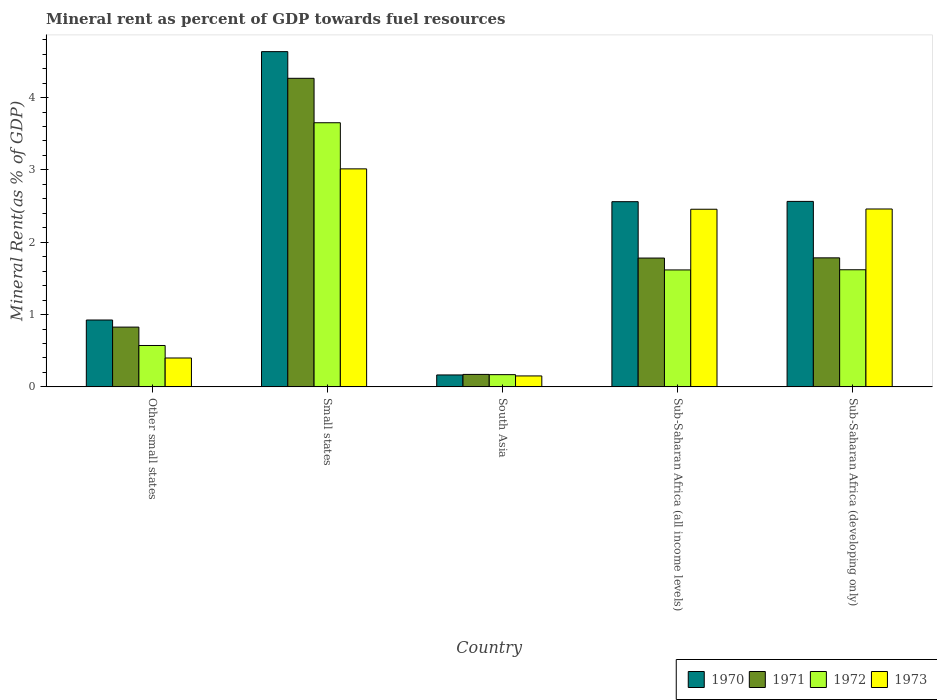Are the number of bars on each tick of the X-axis equal?
Offer a terse response. Yes. How many bars are there on the 1st tick from the left?
Ensure brevity in your answer.  4. How many bars are there on the 4th tick from the right?
Offer a very short reply. 4. What is the label of the 5th group of bars from the left?
Make the answer very short. Sub-Saharan Africa (developing only). What is the mineral rent in 1972 in Sub-Saharan Africa (developing only)?
Your answer should be compact. 1.62. Across all countries, what is the maximum mineral rent in 1973?
Give a very brief answer. 3.01. Across all countries, what is the minimum mineral rent in 1973?
Ensure brevity in your answer.  0.15. In which country was the mineral rent in 1970 maximum?
Make the answer very short. Small states. What is the total mineral rent in 1972 in the graph?
Ensure brevity in your answer.  7.63. What is the difference between the mineral rent in 1973 in Sub-Saharan Africa (all income levels) and that in Sub-Saharan Africa (developing only)?
Keep it short and to the point. -0. What is the difference between the mineral rent in 1971 in Sub-Saharan Africa (all income levels) and the mineral rent in 1972 in South Asia?
Give a very brief answer. 1.61. What is the average mineral rent in 1971 per country?
Keep it short and to the point. 1.77. What is the difference between the mineral rent of/in 1970 and mineral rent of/in 1971 in Sub-Saharan Africa (all income levels)?
Provide a short and direct response. 0.78. What is the ratio of the mineral rent in 1973 in Small states to that in South Asia?
Your answer should be compact. 19.93. Is the mineral rent in 1972 in Other small states less than that in Sub-Saharan Africa (developing only)?
Provide a short and direct response. Yes. What is the difference between the highest and the second highest mineral rent in 1973?
Make the answer very short. -0.55. What is the difference between the highest and the lowest mineral rent in 1972?
Give a very brief answer. 3.48. In how many countries, is the mineral rent in 1973 greater than the average mineral rent in 1973 taken over all countries?
Your response must be concise. 3. Is the sum of the mineral rent in 1972 in Small states and Sub-Saharan Africa (all income levels) greater than the maximum mineral rent in 1970 across all countries?
Make the answer very short. Yes. What does the 3rd bar from the right in Sub-Saharan Africa (all income levels) represents?
Offer a very short reply. 1971. How many bars are there?
Your response must be concise. 20. What is the difference between two consecutive major ticks on the Y-axis?
Keep it short and to the point. 1. Are the values on the major ticks of Y-axis written in scientific E-notation?
Offer a terse response. No. Does the graph contain any zero values?
Your answer should be compact. No. Does the graph contain grids?
Make the answer very short. No. How many legend labels are there?
Provide a short and direct response. 4. What is the title of the graph?
Make the answer very short. Mineral rent as percent of GDP towards fuel resources. What is the label or title of the X-axis?
Keep it short and to the point. Country. What is the label or title of the Y-axis?
Your answer should be compact. Mineral Rent(as % of GDP). What is the Mineral Rent(as % of GDP) in 1970 in Other small states?
Make the answer very short. 0.92. What is the Mineral Rent(as % of GDP) in 1971 in Other small states?
Your answer should be compact. 0.83. What is the Mineral Rent(as % of GDP) in 1972 in Other small states?
Make the answer very short. 0.57. What is the Mineral Rent(as % of GDP) in 1973 in Other small states?
Give a very brief answer. 0.4. What is the Mineral Rent(as % of GDP) of 1970 in Small states?
Keep it short and to the point. 4.63. What is the Mineral Rent(as % of GDP) of 1971 in Small states?
Ensure brevity in your answer.  4.27. What is the Mineral Rent(as % of GDP) of 1972 in Small states?
Keep it short and to the point. 3.65. What is the Mineral Rent(as % of GDP) of 1973 in Small states?
Provide a succinct answer. 3.01. What is the Mineral Rent(as % of GDP) in 1970 in South Asia?
Make the answer very short. 0.16. What is the Mineral Rent(as % of GDP) in 1971 in South Asia?
Give a very brief answer. 0.17. What is the Mineral Rent(as % of GDP) of 1972 in South Asia?
Ensure brevity in your answer.  0.17. What is the Mineral Rent(as % of GDP) of 1973 in South Asia?
Your response must be concise. 0.15. What is the Mineral Rent(as % of GDP) of 1970 in Sub-Saharan Africa (all income levels)?
Offer a very short reply. 2.56. What is the Mineral Rent(as % of GDP) in 1971 in Sub-Saharan Africa (all income levels)?
Your response must be concise. 1.78. What is the Mineral Rent(as % of GDP) in 1972 in Sub-Saharan Africa (all income levels)?
Offer a terse response. 1.62. What is the Mineral Rent(as % of GDP) of 1973 in Sub-Saharan Africa (all income levels)?
Your answer should be compact. 2.46. What is the Mineral Rent(as % of GDP) in 1970 in Sub-Saharan Africa (developing only)?
Ensure brevity in your answer.  2.56. What is the Mineral Rent(as % of GDP) in 1971 in Sub-Saharan Africa (developing only)?
Give a very brief answer. 1.78. What is the Mineral Rent(as % of GDP) of 1972 in Sub-Saharan Africa (developing only)?
Provide a succinct answer. 1.62. What is the Mineral Rent(as % of GDP) of 1973 in Sub-Saharan Africa (developing only)?
Your response must be concise. 2.46. Across all countries, what is the maximum Mineral Rent(as % of GDP) of 1970?
Your answer should be very brief. 4.63. Across all countries, what is the maximum Mineral Rent(as % of GDP) in 1971?
Keep it short and to the point. 4.27. Across all countries, what is the maximum Mineral Rent(as % of GDP) in 1972?
Provide a succinct answer. 3.65. Across all countries, what is the maximum Mineral Rent(as % of GDP) of 1973?
Provide a succinct answer. 3.01. Across all countries, what is the minimum Mineral Rent(as % of GDP) in 1970?
Offer a terse response. 0.16. Across all countries, what is the minimum Mineral Rent(as % of GDP) of 1971?
Your response must be concise. 0.17. Across all countries, what is the minimum Mineral Rent(as % of GDP) of 1972?
Provide a succinct answer. 0.17. Across all countries, what is the minimum Mineral Rent(as % of GDP) in 1973?
Keep it short and to the point. 0.15. What is the total Mineral Rent(as % of GDP) of 1970 in the graph?
Your answer should be very brief. 10.85. What is the total Mineral Rent(as % of GDP) in 1971 in the graph?
Your answer should be compact. 8.83. What is the total Mineral Rent(as % of GDP) of 1972 in the graph?
Provide a short and direct response. 7.63. What is the total Mineral Rent(as % of GDP) of 1973 in the graph?
Offer a terse response. 8.48. What is the difference between the Mineral Rent(as % of GDP) of 1970 in Other small states and that in Small states?
Give a very brief answer. -3.71. What is the difference between the Mineral Rent(as % of GDP) of 1971 in Other small states and that in Small states?
Provide a succinct answer. -3.44. What is the difference between the Mineral Rent(as % of GDP) of 1972 in Other small states and that in Small states?
Ensure brevity in your answer.  -3.08. What is the difference between the Mineral Rent(as % of GDP) in 1973 in Other small states and that in Small states?
Your answer should be very brief. -2.61. What is the difference between the Mineral Rent(as % of GDP) of 1970 in Other small states and that in South Asia?
Your answer should be very brief. 0.76. What is the difference between the Mineral Rent(as % of GDP) in 1971 in Other small states and that in South Asia?
Provide a succinct answer. 0.65. What is the difference between the Mineral Rent(as % of GDP) of 1972 in Other small states and that in South Asia?
Provide a short and direct response. 0.4. What is the difference between the Mineral Rent(as % of GDP) of 1973 in Other small states and that in South Asia?
Your response must be concise. 0.25. What is the difference between the Mineral Rent(as % of GDP) in 1970 in Other small states and that in Sub-Saharan Africa (all income levels)?
Offer a terse response. -1.64. What is the difference between the Mineral Rent(as % of GDP) in 1971 in Other small states and that in Sub-Saharan Africa (all income levels)?
Your response must be concise. -0.95. What is the difference between the Mineral Rent(as % of GDP) in 1972 in Other small states and that in Sub-Saharan Africa (all income levels)?
Keep it short and to the point. -1.04. What is the difference between the Mineral Rent(as % of GDP) of 1973 in Other small states and that in Sub-Saharan Africa (all income levels)?
Ensure brevity in your answer.  -2.06. What is the difference between the Mineral Rent(as % of GDP) of 1970 in Other small states and that in Sub-Saharan Africa (developing only)?
Offer a terse response. -1.64. What is the difference between the Mineral Rent(as % of GDP) in 1971 in Other small states and that in Sub-Saharan Africa (developing only)?
Provide a succinct answer. -0.96. What is the difference between the Mineral Rent(as % of GDP) in 1972 in Other small states and that in Sub-Saharan Africa (developing only)?
Give a very brief answer. -1.05. What is the difference between the Mineral Rent(as % of GDP) in 1973 in Other small states and that in Sub-Saharan Africa (developing only)?
Keep it short and to the point. -2.06. What is the difference between the Mineral Rent(as % of GDP) of 1970 in Small states and that in South Asia?
Your response must be concise. 4.47. What is the difference between the Mineral Rent(as % of GDP) of 1971 in Small states and that in South Asia?
Give a very brief answer. 4.09. What is the difference between the Mineral Rent(as % of GDP) in 1972 in Small states and that in South Asia?
Provide a succinct answer. 3.48. What is the difference between the Mineral Rent(as % of GDP) of 1973 in Small states and that in South Asia?
Keep it short and to the point. 2.86. What is the difference between the Mineral Rent(as % of GDP) in 1970 in Small states and that in Sub-Saharan Africa (all income levels)?
Your answer should be compact. 2.07. What is the difference between the Mineral Rent(as % of GDP) in 1971 in Small states and that in Sub-Saharan Africa (all income levels)?
Offer a terse response. 2.49. What is the difference between the Mineral Rent(as % of GDP) of 1972 in Small states and that in Sub-Saharan Africa (all income levels)?
Your response must be concise. 2.04. What is the difference between the Mineral Rent(as % of GDP) in 1973 in Small states and that in Sub-Saharan Africa (all income levels)?
Make the answer very short. 0.56. What is the difference between the Mineral Rent(as % of GDP) in 1970 in Small states and that in Sub-Saharan Africa (developing only)?
Make the answer very short. 2.07. What is the difference between the Mineral Rent(as % of GDP) of 1971 in Small states and that in Sub-Saharan Africa (developing only)?
Keep it short and to the point. 2.48. What is the difference between the Mineral Rent(as % of GDP) in 1972 in Small states and that in Sub-Saharan Africa (developing only)?
Your answer should be very brief. 2.03. What is the difference between the Mineral Rent(as % of GDP) in 1973 in Small states and that in Sub-Saharan Africa (developing only)?
Give a very brief answer. 0.55. What is the difference between the Mineral Rent(as % of GDP) in 1970 in South Asia and that in Sub-Saharan Africa (all income levels)?
Your answer should be very brief. -2.4. What is the difference between the Mineral Rent(as % of GDP) in 1971 in South Asia and that in Sub-Saharan Africa (all income levels)?
Keep it short and to the point. -1.61. What is the difference between the Mineral Rent(as % of GDP) of 1972 in South Asia and that in Sub-Saharan Africa (all income levels)?
Offer a very short reply. -1.45. What is the difference between the Mineral Rent(as % of GDP) of 1973 in South Asia and that in Sub-Saharan Africa (all income levels)?
Ensure brevity in your answer.  -2.3. What is the difference between the Mineral Rent(as % of GDP) of 1970 in South Asia and that in Sub-Saharan Africa (developing only)?
Provide a succinct answer. -2.4. What is the difference between the Mineral Rent(as % of GDP) of 1971 in South Asia and that in Sub-Saharan Africa (developing only)?
Ensure brevity in your answer.  -1.61. What is the difference between the Mineral Rent(as % of GDP) of 1972 in South Asia and that in Sub-Saharan Africa (developing only)?
Provide a short and direct response. -1.45. What is the difference between the Mineral Rent(as % of GDP) of 1973 in South Asia and that in Sub-Saharan Africa (developing only)?
Offer a very short reply. -2.31. What is the difference between the Mineral Rent(as % of GDP) in 1970 in Sub-Saharan Africa (all income levels) and that in Sub-Saharan Africa (developing only)?
Provide a succinct answer. -0. What is the difference between the Mineral Rent(as % of GDP) of 1971 in Sub-Saharan Africa (all income levels) and that in Sub-Saharan Africa (developing only)?
Offer a terse response. -0. What is the difference between the Mineral Rent(as % of GDP) in 1972 in Sub-Saharan Africa (all income levels) and that in Sub-Saharan Africa (developing only)?
Give a very brief answer. -0. What is the difference between the Mineral Rent(as % of GDP) in 1973 in Sub-Saharan Africa (all income levels) and that in Sub-Saharan Africa (developing only)?
Provide a succinct answer. -0. What is the difference between the Mineral Rent(as % of GDP) of 1970 in Other small states and the Mineral Rent(as % of GDP) of 1971 in Small states?
Keep it short and to the point. -3.34. What is the difference between the Mineral Rent(as % of GDP) in 1970 in Other small states and the Mineral Rent(as % of GDP) in 1972 in Small states?
Give a very brief answer. -2.73. What is the difference between the Mineral Rent(as % of GDP) in 1970 in Other small states and the Mineral Rent(as % of GDP) in 1973 in Small states?
Keep it short and to the point. -2.09. What is the difference between the Mineral Rent(as % of GDP) in 1971 in Other small states and the Mineral Rent(as % of GDP) in 1972 in Small states?
Your response must be concise. -2.83. What is the difference between the Mineral Rent(as % of GDP) of 1971 in Other small states and the Mineral Rent(as % of GDP) of 1973 in Small states?
Your answer should be compact. -2.19. What is the difference between the Mineral Rent(as % of GDP) in 1972 in Other small states and the Mineral Rent(as % of GDP) in 1973 in Small states?
Make the answer very short. -2.44. What is the difference between the Mineral Rent(as % of GDP) of 1970 in Other small states and the Mineral Rent(as % of GDP) of 1971 in South Asia?
Your answer should be compact. 0.75. What is the difference between the Mineral Rent(as % of GDP) in 1970 in Other small states and the Mineral Rent(as % of GDP) in 1972 in South Asia?
Your answer should be very brief. 0.76. What is the difference between the Mineral Rent(as % of GDP) in 1970 in Other small states and the Mineral Rent(as % of GDP) in 1973 in South Asia?
Your answer should be compact. 0.77. What is the difference between the Mineral Rent(as % of GDP) of 1971 in Other small states and the Mineral Rent(as % of GDP) of 1972 in South Asia?
Offer a terse response. 0.66. What is the difference between the Mineral Rent(as % of GDP) of 1971 in Other small states and the Mineral Rent(as % of GDP) of 1973 in South Asia?
Offer a very short reply. 0.68. What is the difference between the Mineral Rent(as % of GDP) in 1972 in Other small states and the Mineral Rent(as % of GDP) in 1973 in South Asia?
Your answer should be compact. 0.42. What is the difference between the Mineral Rent(as % of GDP) in 1970 in Other small states and the Mineral Rent(as % of GDP) in 1971 in Sub-Saharan Africa (all income levels)?
Make the answer very short. -0.86. What is the difference between the Mineral Rent(as % of GDP) of 1970 in Other small states and the Mineral Rent(as % of GDP) of 1972 in Sub-Saharan Africa (all income levels)?
Keep it short and to the point. -0.69. What is the difference between the Mineral Rent(as % of GDP) in 1970 in Other small states and the Mineral Rent(as % of GDP) in 1973 in Sub-Saharan Africa (all income levels)?
Ensure brevity in your answer.  -1.53. What is the difference between the Mineral Rent(as % of GDP) in 1971 in Other small states and the Mineral Rent(as % of GDP) in 1972 in Sub-Saharan Africa (all income levels)?
Offer a terse response. -0.79. What is the difference between the Mineral Rent(as % of GDP) of 1971 in Other small states and the Mineral Rent(as % of GDP) of 1973 in Sub-Saharan Africa (all income levels)?
Ensure brevity in your answer.  -1.63. What is the difference between the Mineral Rent(as % of GDP) of 1972 in Other small states and the Mineral Rent(as % of GDP) of 1973 in Sub-Saharan Africa (all income levels)?
Give a very brief answer. -1.88. What is the difference between the Mineral Rent(as % of GDP) in 1970 in Other small states and the Mineral Rent(as % of GDP) in 1971 in Sub-Saharan Africa (developing only)?
Give a very brief answer. -0.86. What is the difference between the Mineral Rent(as % of GDP) in 1970 in Other small states and the Mineral Rent(as % of GDP) in 1972 in Sub-Saharan Africa (developing only)?
Offer a very short reply. -0.69. What is the difference between the Mineral Rent(as % of GDP) in 1970 in Other small states and the Mineral Rent(as % of GDP) in 1973 in Sub-Saharan Africa (developing only)?
Your response must be concise. -1.53. What is the difference between the Mineral Rent(as % of GDP) of 1971 in Other small states and the Mineral Rent(as % of GDP) of 1972 in Sub-Saharan Africa (developing only)?
Make the answer very short. -0.79. What is the difference between the Mineral Rent(as % of GDP) of 1971 in Other small states and the Mineral Rent(as % of GDP) of 1973 in Sub-Saharan Africa (developing only)?
Your response must be concise. -1.63. What is the difference between the Mineral Rent(as % of GDP) in 1972 in Other small states and the Mineral Rent(as % of GDP) in 1973 in Sub-Saharan Africa (developing only)?
Give a very brief answer. -1.89. What is the difference between the Mineral Rent(as % of GDP) of 1970 in Small states and the Mineral Rent(as % of GDP) of 1971 in South Asia?
Provide a succinct answer. 4.46. What is the difference between the Mineral Rent(as % of GDP) of 1970 in Small states and the Mineral Rent(as % of GDP) of 1972 in South Asia?
Your response must be concise. 4.47. What is the difference between the Mineral Rent(as % of GDP) in 1970 in Small states and the Mineral Rent(as % of GDP) in 1973 in South Asia?
Ensure brevity in your answer.  4.48. What is the difference between the Mineral Rent(as % of GDP) of 1971 in Small states and the Mineral Rent(as % of GDP) of 1972 in South Asia?
Provide a short and direct response. 4.1. What is the difference between the Mineral Rent(as % of GDP) in 1971 in Small states and the Mineral Rent(as % of GDP) in 1973 in South Asia?
Keep it short and to the point. 4.11. What is the difference between the Mineral Rent(as % of GDP) in 1972 in Small states and the Mineral Rent(as % of GDP) in 1973 in South Asia?
Give a very brief answer. 3.5. What is the difference between the Mineral Rent(as % of GDP) in 1970 in Small states and the Mineral Rent(as % of GDP) in 1971 in Sub-Saharan Africa (all income levels)?
Offer a terse response. 2.85. What is the difference between the Mineral Rent(as % of GDP) in 1970 in Small states and the Mineral Rent(as % of GDP) in 1972 in Sub-Saharan Africa (all income levels)?
Offer a terse response. 3.02. What is the difference between the Mineral Rent(as % of GDP) in 1970 in Small states and the Mineral Rent(as % of GDP) in 1973 in Sub-Saharan Africa (all income levels)?
Your answer should be compact. 2.18. What is the difference between the Mineral Rent(as % of GDP) in 1971 in Small states and the Mineral Rent(as % of GDP) in 1972 in Sub-Saharan Africa (all income levels)?
Provide a short and direct response. 2.65. What is the difference between the Mineral Rent(as % of GDP) of 1971 in Small states and the Mineral Rent(as % of GDP) of 1973 in Sub-Saharan Africa (all income levels)?
Make the answer very short. 1.81. What is the difference between the Mineral Rent(as % of GDP) of 1972 in Small states and the Mineral Rent(as % of GDP) of 1973 in Sub-Saharan Africa (all income levels)?
Give a very brief answer. 1.2. What is the difference between the Mineral Rent(as % of GDP) of 1970 in Small states and the Mineral Rent(as % of GDP) of 1971 in Sub-Saharan Africa (developing only)?
Provide a succinct answer. 2.85. What is the difference between the Mineral Rent(as % of GDP) of 1970 in Small states and the Mineral Rent(as % of GDP) of 1972 in Sub-Saharan Africa (developing only)?
Your answer should be compact. 3.02. What is the difference between the Mineral Rent(as % of GDP) of 1970 in Small states and the Mineral Rent(as % of GDP) of 1973 in Sub-Saharan Africa (developing only)?
Provide a succinct answer. 2.18. What is the difference between the Mineral Rent(as % of GDP) of 1971 in Small states and the Mineral Rent(as % of GDP) of 1972 in Sub-Saharan Africa (developing only)?
Your answer should be compact. 2.65. What is the difference between the Mineral Rent(as % of GDP) in 1971 in Small states and the Mineral Rent(as % of GDP) in 1973 in Sub-Saharan Africa (developing only)?
Offer a terse response. 1.81. What is the difference between the Mineral Rent(as % of GDP) of 1972 in Small states and the Mineral Rent(as % of GDP) of 1973 in Sub-Saharan Africa (developing only)?
Ensure brevity in your answer.  1.19. What is the difference between the Mineral Rent(as % of GDP) in 1970 in South Asia and the Mineral Rent(as % of GDP) in 1971 in Sub-Saharan Africa (all income levels)?
Offer a very short reply. -1.62. What is the difference between the Mineral Rent(as % of GDP) in 1970 in South Asia and the Mineral Rent(as % of GDP) in 1972 in Sub-Saharan Africa (all income levels)?
Give a very brief answer. -1.45. What is the difference between the Mineral Rent(as % of GDP) in 1970 in South Asia and the Mineral Rent(as % of GDP) in 1973 in Sub-Saharan Africa (all income levels)?
Provide a succinct answer. -2.29. What is the difference between the Mineral Rent(as % of GDP) of 1971 in South Asia and the Mineral Rent(as % of GDP) of 1972 in Sub-Saharan Africa (all income levels)?
Offer a terse response. -1.44. What is the difference between the Mineral Rent(as % of GDP) of 1971 in South Asia and the Mineral Rent(as % of GDP) of 1973 in Sub-Saharan Africa (all income levels)?
Offer a terse response. -2.28. What is the difference between the Mineral Rent(as % of GDP) in 1972 in South Asia and the Mineral Rent(as % of GDP) in 1973 in Sub-Saharan Africa (all income levels)?
Ensure brevity in your answer.  -2.29. What is the difference between the Mineral Rent(as % of GDP) of 1970 in South Asia and the Mineral Rent(as % of GDP) of 1971 in Sub-Saharan Africa (developing only)?
Give a very brief answer. -1.62. What is the difference between the Mineral Rent(as % of GDP) of 1970 in South Asia and the Mineral Rent(as % of GDP) of 1972 in Sub-Saharan Africa (developing only)?
Provide a short and direct response. -1.45. What is the difference between the Mineral Rent(as % of GDP) in 1970 in South Asia and the Mineral Rent(as % of GDP) in 1973 in Sub-Saharan Africa (developing only)?
Offer a very short reply. -2.29. What is the difference between the Mineral Rent(as % of GDP) of 1971 in South Asia and the Mineral Rent(as % of GDP) of 1972 in Sub-Saharan Africa (developing only)?
Provide a short and direct response. -1.45. What is the difference between the Mineral Rent(as % of GDP) in 1971 in South Asia and the Mineral Rent(as % of GDP) in 1973 in Sub-Saharan Africa (developing only)?
Give a very brief answer. -2.29. What is the difference between the Mineral Rent(as % of GDP) of 1972 in South Asia and the Mineral Rent(as % of GDP) of 1973 in Sub-Saharan Africa (developing only)?
Ensure brevity in your answer.  -2.29. What is the difference between the Mineral Rent(as % of GDP) in 1970 in Sub-Saharan Africa (all income levels) and the Mineral Rent(as % of GDP) in 1971 in Sub-Saharan Africa (developing only)?
Your response must be concise. 0.78. What is the difference between the Mineral Rent(as % of GDP) of 1970 in Sub-Saharan Africa (all income levels) and the Mineral Rent(as % of GDP) of 1972 in Sub-Saharan Africa (developing only)?
Make the answer very short. 0.94. What is the difference between the Mineral Rent(as % of GDP) of 1970 in Sub-Saharan Africa (all income levels) and the Mineral Rent(as % of GDP) of 1973 in Sub-Saharan Africa (developing only)?
Keep it short and to the point. 0.1. What is the difference between the Mineral Rent(as % of GDP) of 1971 in Sub-Saharan Africa (all income levels) and the Mineral Rent(as % of GDP) of 1972 in Sub-Saharan Africa (developing only)?
Give a very brief answer. 0.16. What is the difference between the Mineral Rent(as % of GDP) of 1971 in Sub-Saharan Africa (all income levels) and the Mineral Rent(as % of GDP) of 1973 in Sub-Saharan Africa (developing only)?
Ensure brevity in your answer.  -0.68. What is the difference between the Mineral Rent(as % of GDP) in 1972 in Sub-Saharan Africa (all income levels) and the Mineral Rent(as % of GDP) in 1973 in Sub-Saharan Africa (developing only)?
Your answer should be compact. -0.84. What is the average Mineral Rent(as % of GDP) of 1970 per country?
Your answer should be very brief. 2.17. What is the average Mineral Rent(as % of GDP) in 1971 per country?
Provide a short and direct response. 1.77. What is the average Mineral Rent(as % of GDP) in 1972 per country?
Give a very brief answer. 1.53. What is the average Mineral Rent(as % of GDP) in 1973 per country?
Your response must be concise. 1.7. What is the difference between the Mineral Rent(as % of GDP) of 1970 and Mineral Rent(as % of GDP) of 1971 in Other small states?
Your answer should be very brief. 0.1. What is the difference between the Mineral Rent(as % of GDP) in 1970 and Mineral Rent(as % of GDP) in 1972 in Other small states?
Offer a terse response. 0.35. What is the difference between the Mineral Rent(as % of GDP) of 1970 and Mineral Rent(as % of GDP) of 1973 in Other small states?
Offer a terse response. 0.53. What is the difference between the Mineral Rent(as % of GDP) of 1971 and Mineral Rent(as % of GDP) of 1972 in Other small states?
Provide a succinct answer. 0.25. What is the difference between the Mineral Rent(as % of GDP) of 1971 and Mineral Rent(as % of GDP) of 1973 in Other small states?
Make the answer very short. 0.43. What is the difference between the Mineral Rent(as % of GDP) in 1972 and Mineral Rent(as % of GDP) in 1973 in Other small states?
Offer a terse response. 0.17. What is the difference between the Mineral Rent(as % of GDP) of 1970 and Mineral Rent(as % of GDP) of 1971 in Small states?
Your answer should be very brief. 0.37. What is the difference between the Mineral Rent(as % of GDP) of 1970 and Mineral Rent(as % of GDP) of 1973 in Small states?
Give a very brief answer. 1.62. What is the difference between the Mineral Rent(as % of GDP) of 1971 and Mineral Rent(as % of GDP) of 1972 in Small states?
Provide a succinct answer. 0.61. What is the difference between the Mineral Rent(as % of GDP) in 1971 and Mineral Rent(as % of GDP) in 1973 in Small states?
Make the answer very short. 1.25. What is the difference between the Mineral Rent(as % of GDP) in 1972 and Mineral Rent(as % of GDP) in 1973 in Small states?
Ensure brevity in your answer.  0.64. What is the difference between the Mineral Rent(as % of GDP) of 1970 and Mineral Rent(as % of GDP) of 1971 in South Asia?
Offer a very short reply. -0.01. What is the difference between the Mineral Rent(as % of GDP) in 1970 and Mineral Rent(as % of GDP) in 1972 in South Asia?
Keep it short and to the point. -0. What is the difference between the Mineral Rent(as % of GDP) in 1970 and Mineral Rent(as % of GDP) in 1973 in South Asia?
Keep it short and to the point. 0.01. What is the difference between the Mineral Rent(as % of GDP) in 1971 and Mineral Rent(as % of GDP) in 1972 in South Asia?
Provide a succinct answer. 0. What is the difference between the Mineral Rent(as % of GDP) in 1971 and Mineral Rent(as % of GDP) in 1973 in South Asia?
Your answer should be very brief. 0.02. What is the difference between the Mineral Rent(as % of GDP) in 1972 and Mineral Rent(as % of GDP) in 1973 in South Asia?
Your response must be concise. 0.02. What is the difference between the Mineral Rent(as % of GDP) in 1970 and Mineral Rent(as % of GDP) in 1971 in Sub-Saharan Africa (all income levels)?
Provide a short and direct response. 0.78. What is the difference between the Mineral Rent(as % of GDP) in 1970 and Mineral Rent(as % of GDP) in 1972 in Sub-Saharan Africa (all income levels)?
Your response must be concise. 0.94. What is the difference between the Mineral Rent(as % of GDP) in 1970 and Mineral Rent(as % of GDP) in 1973 in Sub-Saharan Africa (all income levels)?
Provide a short and direct response. 0.1. What is the difference between the Mineral Rent(as % of GDP) of 1971 and Mineral Rent(as % of GDP) of 1972 in Sub-Saharan Africa (all income levels)?
Offer a terse response. 0.16. What is the difference between the Mineral Rent(as % of GDP) of 1971 and Mineral Rent(as % of GDP) of 1973 in Sub-Saharan Africa (all income levels)?
Offer a very short reply. -0.67. What is the difference between the Mineral Rent(as % of GDP) of 1972 and Mineral Rent(as % of GDP) of 1973 in Sub-Saharan Africa (all income levels)?
Give a very brief answer. -0.84. What is the difference between the Mineral Rent(as % of GDP) of 1970 and Mineral Rent(as % of GDP) of 1971 in Sub-Saharan Africa (developing only)?
Offer a terse response. 0.78. What is the difference between the Mineral Rent(as % of GDP) of 1970 and Mineral Rent(as % of GDP) of 1972 in Sub-Saharan Africa (developing only)?
Your response must be concise. 0.95. What is the difference between the Mineral Rent(as % of GDP) of 1970 and Mineral Rent(as % of GDP) of 1973 in Sub-Saharan Africa (developing only)?
Offer a very short reply. 0.1. What is the difference between the Mineral Rent(as % of GDP) in 1971 and Mineral Rent(as % of GDP) in 1972 in Sub-Saharan Africa (developing only)?
Provide a succinct answer. 0.16. What is the difference between the Mineral Rent(as % of GDP) in 1971 and Mineral Rent(as % of GDP) in 1973 in Sub-Saharan Africa (developing only)?
Provide a succinct answer. -0.68. What is the difference between the Mineral Rent(as % of GDP) of 1972 and Mineral Rent(as % of GDP) of 1973 in Sub-Saharan Africa (developing only)?
Ensure brevity in your answer.  -0.84. What is the ratio of the Mineral Rent(as % of GDP) in 1970 in Other small states to that in Small states?
Give a very brief answer. 0.2. What is the ratio of the Mineral Rent(as % of GDP) in 1971 in Other small states to that in Small states?
Your answer should be very brief. 0.19. What is the ratio of the Mineral Rent(as % of GDP) in 1972 in Other small states to that in Small states?
Keep it short and to the point. 0.16. What is the ratio of the Mineral Rent(as % of GDP) in 1973 in Other small states to that in Small states?
Make the answer very short. 0.13. What is the ratio of the Mineral Rent(as % of GDP) in 1970 in Other small states to that in South Asia?
Offer a very short reply. 5.61. What is the ratio of the Mineral Rent(as % of GDP) of 1971 in Other small states to that in South Asia?
Offer a very short reply. 4.8. What is the ratio of the Mineral Rent(as % of GDP) of 1972 in Other small states to that in South Asia?
Ensure brevity in your answer.  3.38. What is the ratio of the Mineral Rent(as % of GDP) in 1973 in Other small states to that in South Asia?
Provide a short and direct response. 2.64. What is the ratio of the Mineral Rent(as % of GDP) in 1970 in Other small states to that in Sub-Saharan Africa (all income levels)?
Make the answer very short. 0.36. What is the ratio of the Mineral Rent(as % of GDP) of 1971 in Other small states to that in Sub-Saharan Africa (all income levels)?
Your answer should be very brief. 0.46. What is the ratio of the Mineral Rent(as % of GDP) of 1972 in Other small states to that in Sub-Saharan Africa (all income levels)?
Your response must be concise. 0.35. What is the ratio of the Mineral Rent(as % of GDP) in 1973 in Other small states to that in Sub-Saharan Africa (all income levels)?
Offer a terse response. 0.16. What is the ratio of the Mineral Rent(as % of GDP) in 1970 in Other small states to that in Sub-Saharan Africa (developing only)?
Make the answer very short. 0.36. What is the ratio of the Mineral Rent(as % of GDP) of 1971 in Other small states to that in Sub-Saharan Africa (developing only)?
Make the answer very short. 0.46. What is the ratio of the Mineral Rent(as % of GDP) of 1972 in Other small states to that in Sub-Saharan Africa (developing only)?
Keep it short and to the point. 0.35. What is the ratio of the Mineral Rent(as % of GDP) of 1973 in Other small states to that in Sub-Saharan Africa (developing only)?
Provide a short and direct response. 0.16. What is the ratio of the Mineral Rent(as % of GDP) in 1970 in Small states to that in South Asia?
Your response must be concise. 28.13. What is the ratio of the Mineral Rent(as % of GDP) of 1971 in Small states to that in South Asia?
Your answer should be very brief. 24.77. What is the ratio of the Mineral Rent(as % of GDP) in 1972 in Small states to that in South Asia?
Give a very brief answer. 21.6. What is the ratio of the Mineral Rent(as % of GDP) of 1973 in Small states to that in South Asia?
Provide a short and direct response. 19.93. What is the ratio of the Mineral Rent(as % of GDP) in 1970 in Small states to that in Sub-Saharan Africa (all income levels)?
Ensure brevity in your answer.  1.81. What is the ratio of the Mineral Rent(as % of GDP) in 1971 in Small states to that in Sub-Saharan Africa (all income levels)?
Give a very brief answer. 2.4. What is the ratio of the Mineral Rent(as % of GDP) of 1972 in Small states to that in Sub-Saharan Africa (all income levels)?
Keep it short and to the point. 2.26. What is the ratio of the Mineral Rent(as % of GDP) of 1973 in Small states to that in Sub-Saharan Africa (all income levels)?
Give a very brief answer. 1.23. What is the ratio of the Mineral Rent(as % of GDP) of 1970 in Small states to that in Sub-Saharan Africa (developing only)?
Give a very brief answer. 1.81. What is the ratio of the Mineral Rent(as % of GDP) of 1971 in Small states to that in Sub-Saharan Africa (developing only)?
Your answer should be compact. 2.39. What is the ratio of the Mineral Rent(as % of GDP) in 1972 in Small states to that in Sub-Saharan Africa (developing only)?
Make the answer very short. 2.26. What is the ratio of the Mineral Rent(as % of GDP) of 1973 in Small states to that in Sub-Saharan Africa (developing only)?
Offer a terse response. 1.23. What is the ratio of the Mineral Rent(as % of GDP) of 1970 in South Asia to that in Sub-Saharan Africa (all income levels)?
Keep it short and to the point. 0.06. What is the ratio of the Mineral Rent(as % of GDP) in 1971 in South Asia to that in Sub-Saharan Africa (all income levels)?
Your answer should be very brief. 0.1. What is the ratio of the Mineral Rent(as % of GDP) of 1972 in South Asia to that in Sub-Saharan Africa (all income levels)?
Your response must be concise. 0.1. What is the ratio of the Mineral Rent(as % of GDP) of 1973 in South Asia to that in Sub-Saharan Africa (all income levels)?
Make the answer very short. 0.06. What is the ratio of the Mineral Rent(as % of GDP) in 1970 in South Asia to that in Sub-Saharan Africa (developing only)?
Offer a very short reply. 0.06. What is the ratio of the Mineral Rent(as % of GDP) in 1971 in South Asia to that in Sub-Saharan Africa (developing only)?
Give a very brief answer. 0.1. What is the ratio of the Mineral Rent(as % of GDP) of 1972 in South Asia to that in Sub-Saharan Africa (developing only)?
Give a very brief answer. 0.1. What is the ratio of the Mineral Rent(as % of GDP) in 1973 in South Asia to that in Sub-Saharan Africa (developing only)?
Offer a very short reply. 0.06. What is the ratio of the Mineral Rent(as % of GDP) in 1971 in Sub-Saharan Africa (all income levels) to that in Sub-Saharan Africa (developing only)?
Your answer should be very brief. 1. What is the difference between the highest and the second highest Mineral Rent(as % of GDP) of 1970?
Provide a succinct answer. 2.07. What is the difference between the highest and the second highest Mineral Rent(as % of GDP) in 1971?
Your response must be concise. 2.48. What is the difference between the highest and the second highest Mineral Rent(as % of GDP) in 1972?
Ensure brevity in your answer.  2.03. What is the difference between the highest and the second highest Mineral Rent(as % of GDP) of 1973?
Give a very brief answer. 0.55. What is the difference between the highest and the lowest Mineral Rent(as % of GDP) in 1970?
Your answer should be compact. 4.47. What is the difference between the highest and the lowest Mineral Rent(as % of GDP) of 1971?
Offer a very short reply. 4.09. What is the difference between the highest and the lowest Mineral Rent(as % of GDP) of 1972?
Offer a very short reply. 3.48. What is the difference between the highest and the lowest Mineral Rent(as % of GDP) in 1973?
Offer a very short reply. 2.86. 